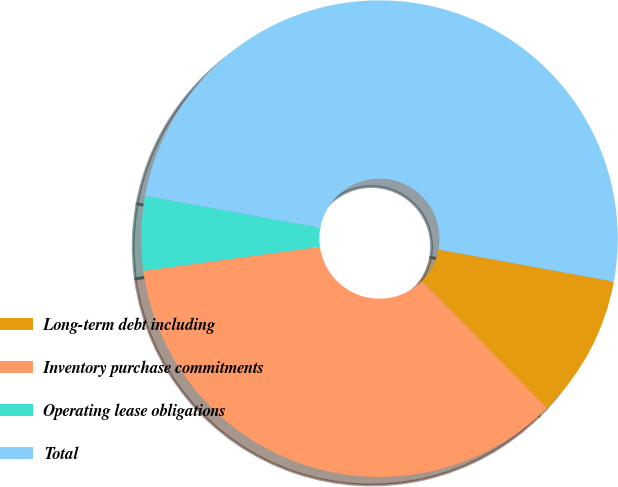Convert chart to OTSL. <chart><loc_0><loc_0><loc_500><loc_500><pie_chart><fcel>Long-term debt including<fcel>Inventory purchase commitments<fcel>Operating lease obligations<fcel>Total<nl><fcel>9.7%<fcel>35.26%<fcel>5.03%<fcel>50.01%<nl></chart> 